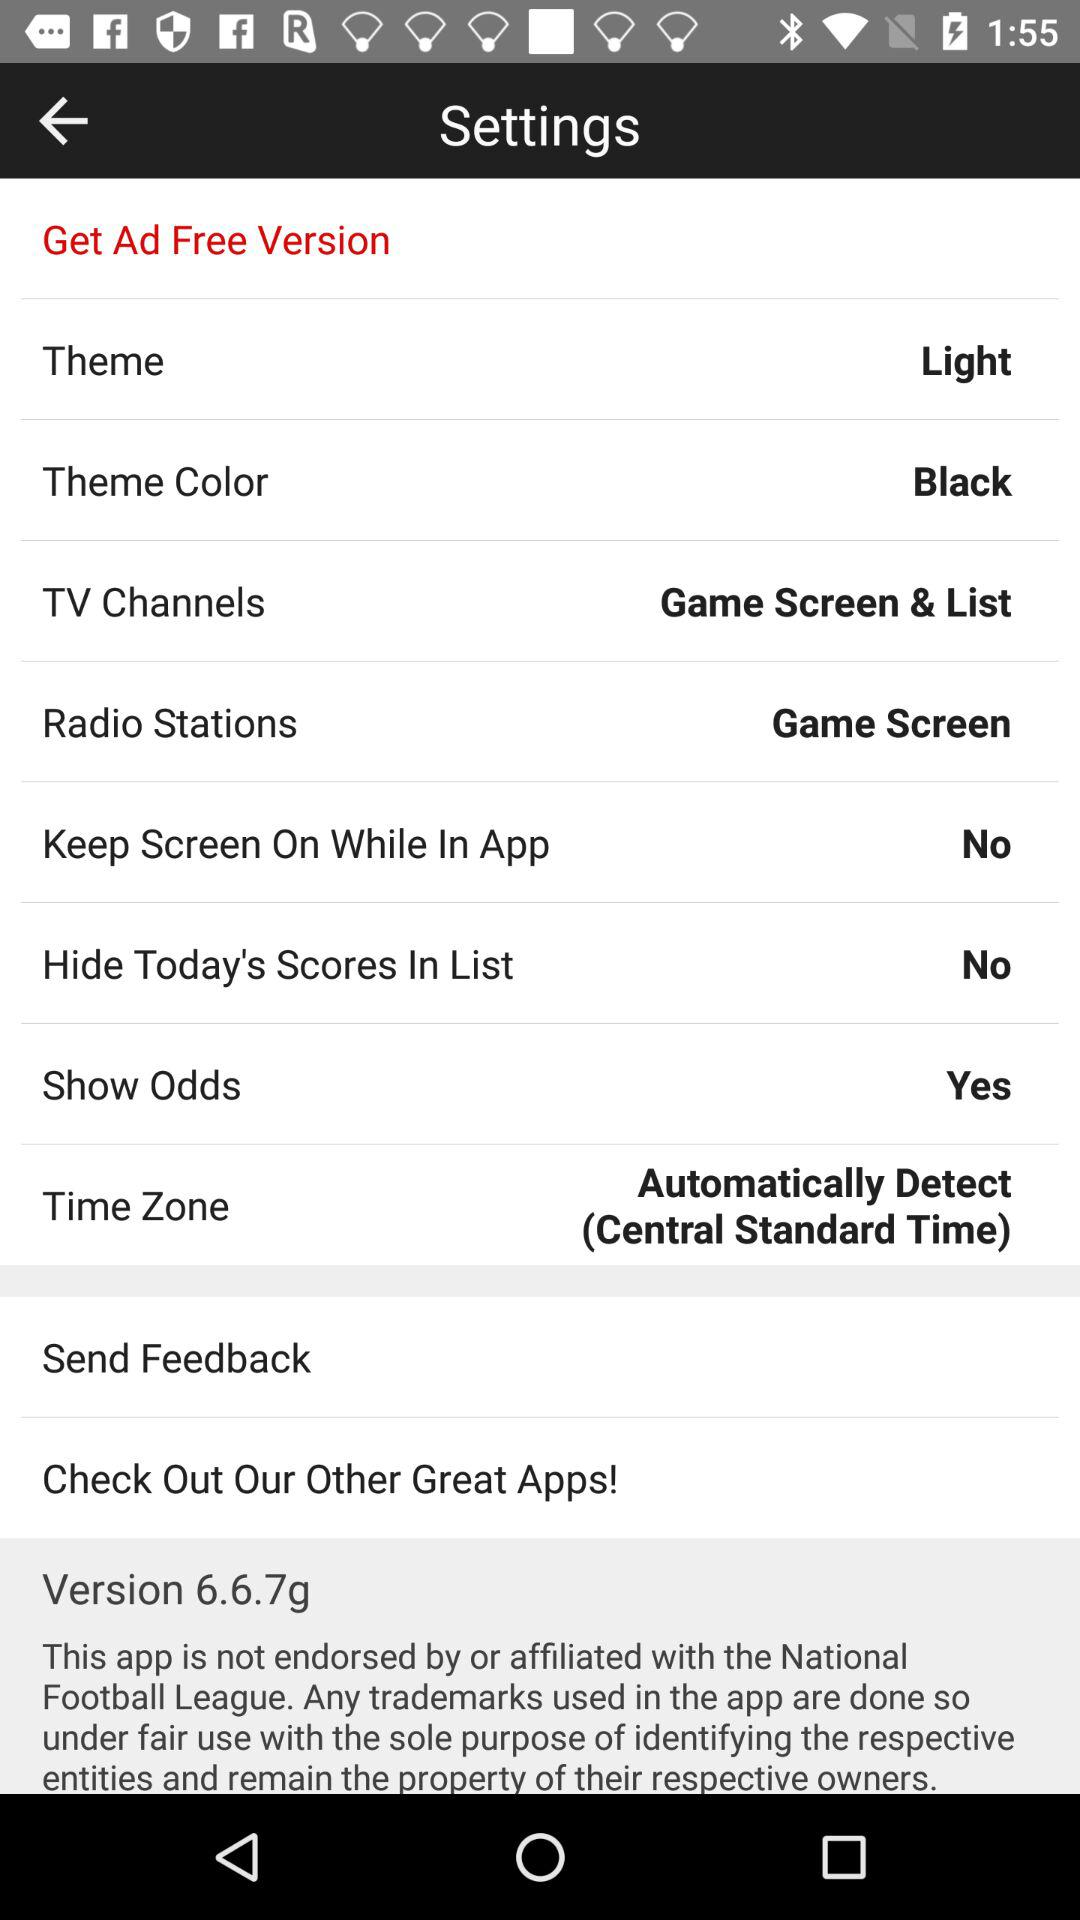What is the theme color? The theme color is black. 